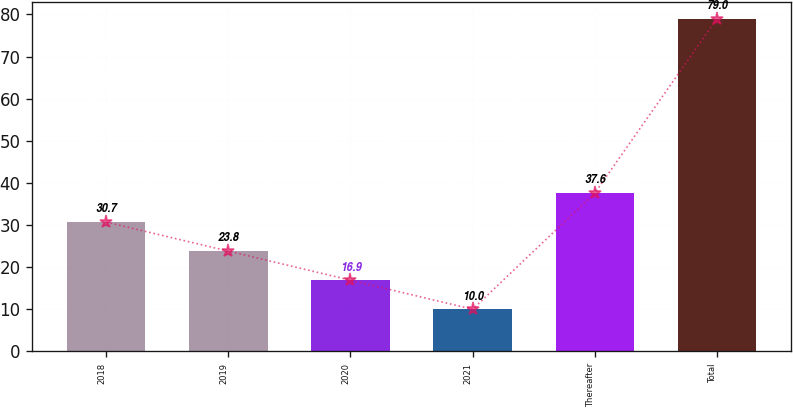<chart> <loc_0><loc_0><loc_500><loc_500><bar_chart><fcel>2018<fcel>2019<fcel>2020<fcel>2021<fcel>Thereafter<fcel>Total<nl><fcel>30.7<fcel>23.8<fcel>16.9<fcel>10<fcel>37.6<fcel>79<nl></chart> 